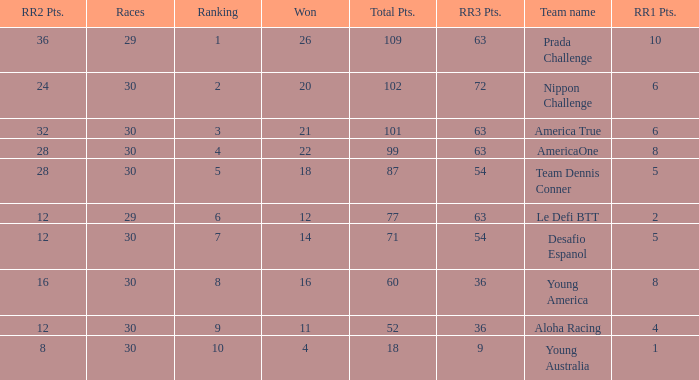Name the total number of rr2 pts for won being 11 1.0. 